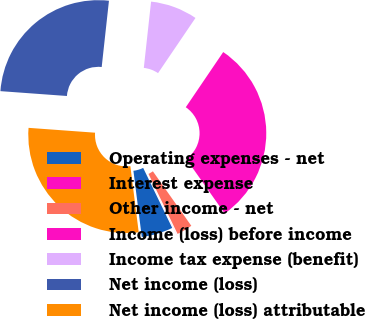Convert chart. <chart><loc_0><loc_0><loc_500><loc_500><pie_chart><fcel>Operating expenses - net<fcel>Interest expense<fcel>Other income - net<fcel>Income (loss) before income<fcel>Income tax expense (benefit)<fcel>Net income (loss)<fcel>Net income (loss) attributable<nl><fcel>5.17%<fcel>0.01%<fcel>2.59%<fcel>30.74%<fcel>7.75%<fcel>25.58%<fcel>28.16%<nl></chart> 